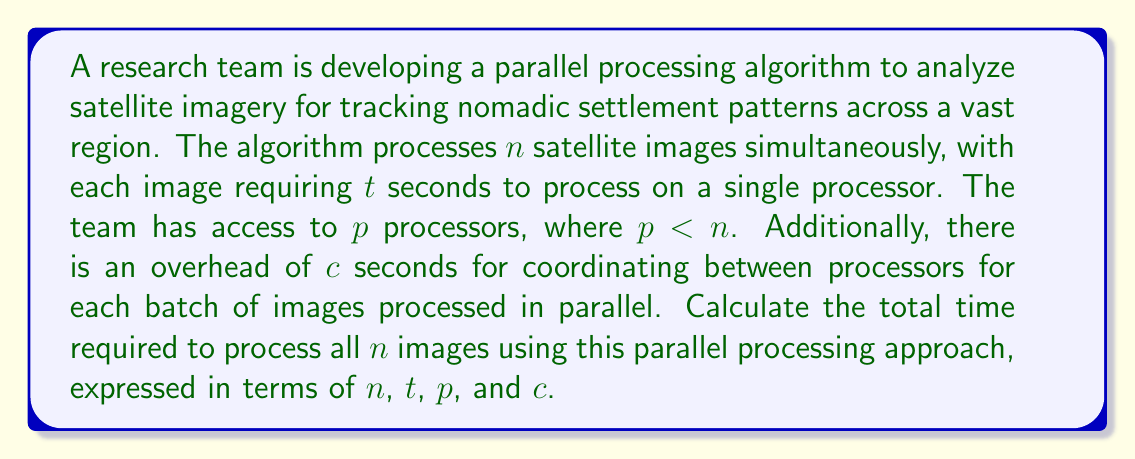Show me your answer to this math problem. To solve this problem, we need to consider the following steps:

1. Determine the number of batches required to process all images:
   The number of batches = $\ceil{\frac{n}{p}}$, where $\ceil{}$ denotes the ceiling function.

2. Calculate the time to process one batch of images:
   - Processing time for one batch = $t$ seconds (since all images in a batch are processed simultaneously)
   - Coordination overhead for one batch = $c$ seconds
   - Total time for one batch = $t + c$ seconds

3. Calculate the total time for all batches:
   Total time = Number of batches × Time per batch
   
   $$T = \ceil{\frac{n}{p}} \times (t + c)$$

4. Simplify the expression:
   $$T = \left(\frac{n}{p} + \left\{\frac{n}{p}\right\}\right) \times (t + c)$$
   where $\left\{\frac{n}{p}\right\}$ represents the fractional part of $\frac{n}{p}$.

This formula gives us the total time required to process all $n$ images using $p$ processors, considering the processing time $t$ for each image and the coordination overhead $c$ for each batch.
Answer: $$T = \ceil{\frac{n}{p}} \times (t + c)$$ 